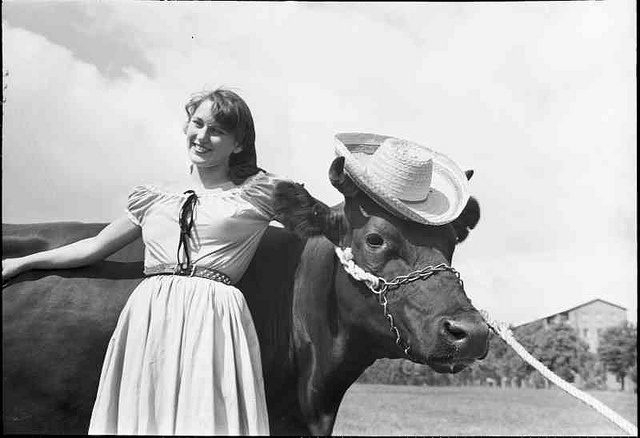Describe the objects in this image and their specific colors. I can see cow in black, gray, and lightgray tones and people in black, lightgray, darkgray, and gray tones in this image. 